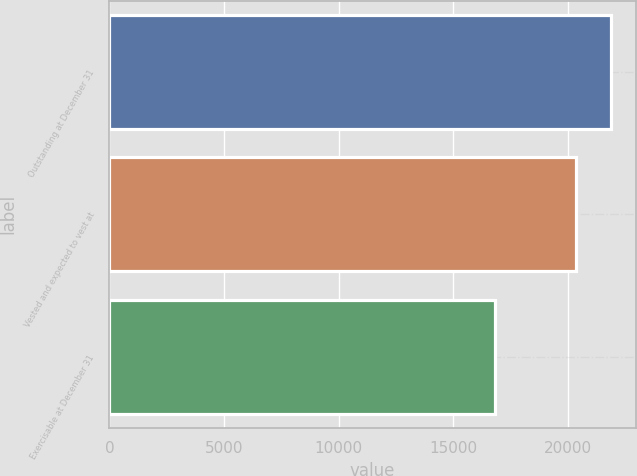Convert chart. <chart><loc_0><loc_0><loc_500><loc_500><bar_chart><fcel>Outstanding at December 31<fcel>Vested and expected to vest at<fcel>Exercisable at December 31<nl><fcel>21862<fcel>20367<fcel>16829<nl></chart> 